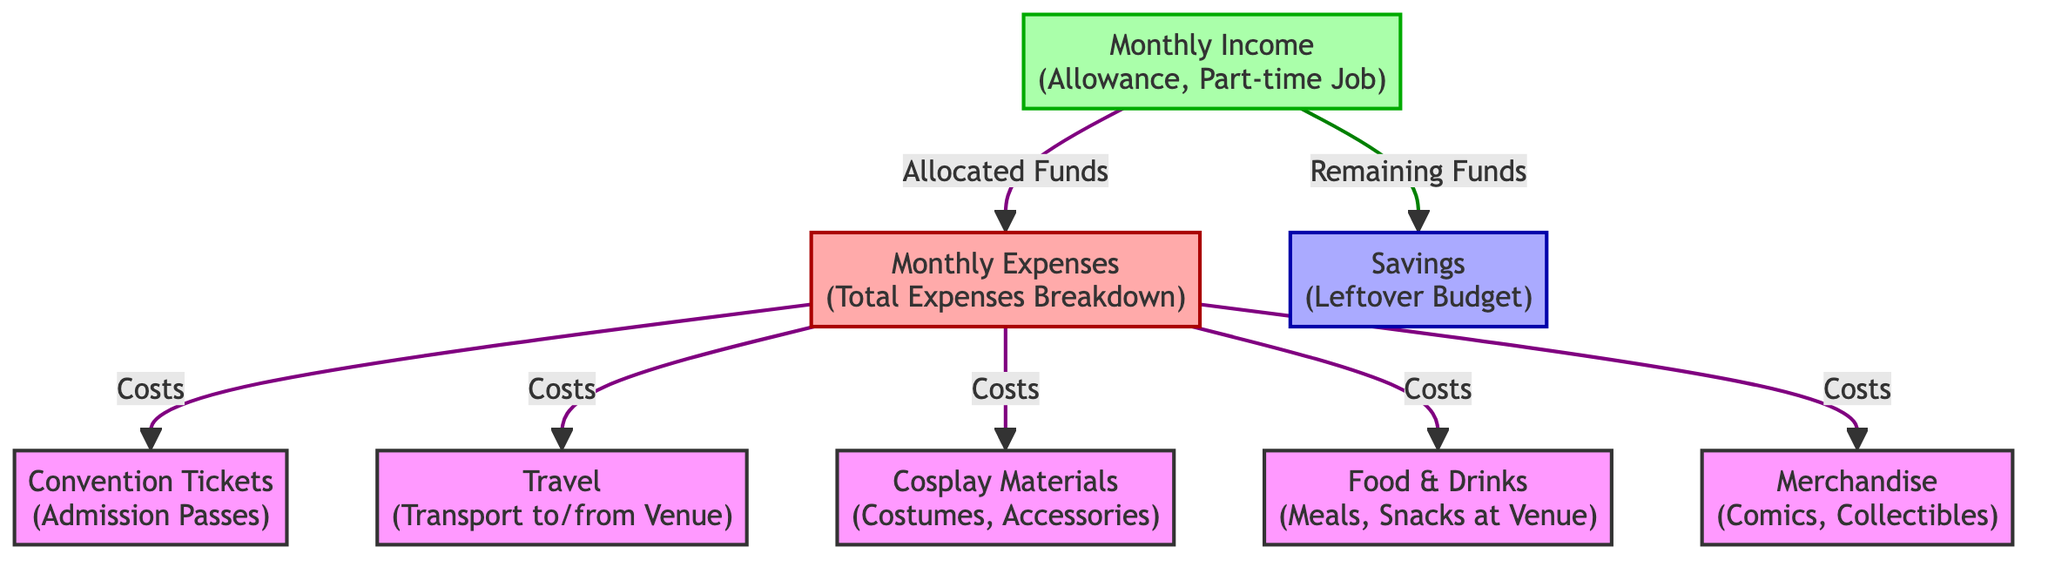What's the main source of income in this budget? The main source of income is represented by the "Monthly Income" node, which indicates funds from an allowance or a part-time job. This node is the starting point of the budget breakdown, feeding into the expenses and savings.
Answer: Monthly Income How many expense categories are listed? There are five expense categories shown: Convention Tickets, Travel, Cosplay Materials, Food & Drinks, and Merchandise. Each of these categories is a separate node under the Monthly Expenses node.
Answer: Five Which expense category is directly linked to convention-related costs? The "Convention Tickets" category is specifically mentioned under the Monthly Expenses, indicating it is a direct cost associated with attending the convention.
Answer: Convention Tickets What happens to the leftover funds? The leftover funds from the monthly income are directed to savings. The diagram shows a link from income to the savings node, indicating that any surplus after expenses contributes to savings.
Answer: Savings How are expenses categorized in the diagram? Expenses are categorized under a single node labeled "Monthly Expenses," which is further broken down into individual cost categories like Travel and Merchandise. This hierarchical structure indicates that all these expenses roll up to the main expense category.
Answer: Monthly Expenses What color is used to represent savings in the diagram? The savings node is highlighted with a blue color defined for the "savings" class in the diagram. This visual cue helps differentiate savings from income and expenses.
Answer: Blue Which of the following expenses is not related to the convention itself: Travel, Merchandise, or Rent? The expense "Rent" is not depicted in this diagram; it primarily focuses on costs associated specifically with attending the comic convention, excluding general living expenses like rent.
Answer: Rent Explain how income influences the savings amount. The income node indicates that some portion of the monthly income is allocated to expenses, while the remaining funds are directed to savings. Therefore, the total amount of savings is determined by subtracting total expenses from total income.
Answer: Remaining Funds 